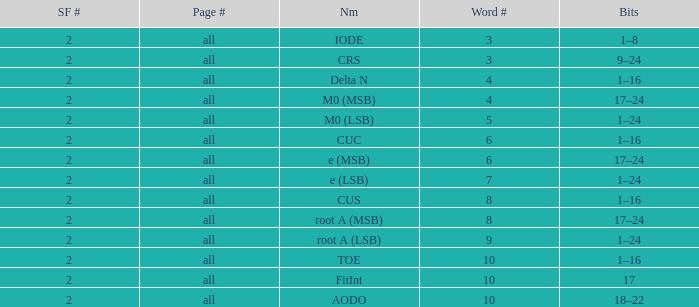What is the page count and word count greater than 5 with Bits of 18–22? All. 